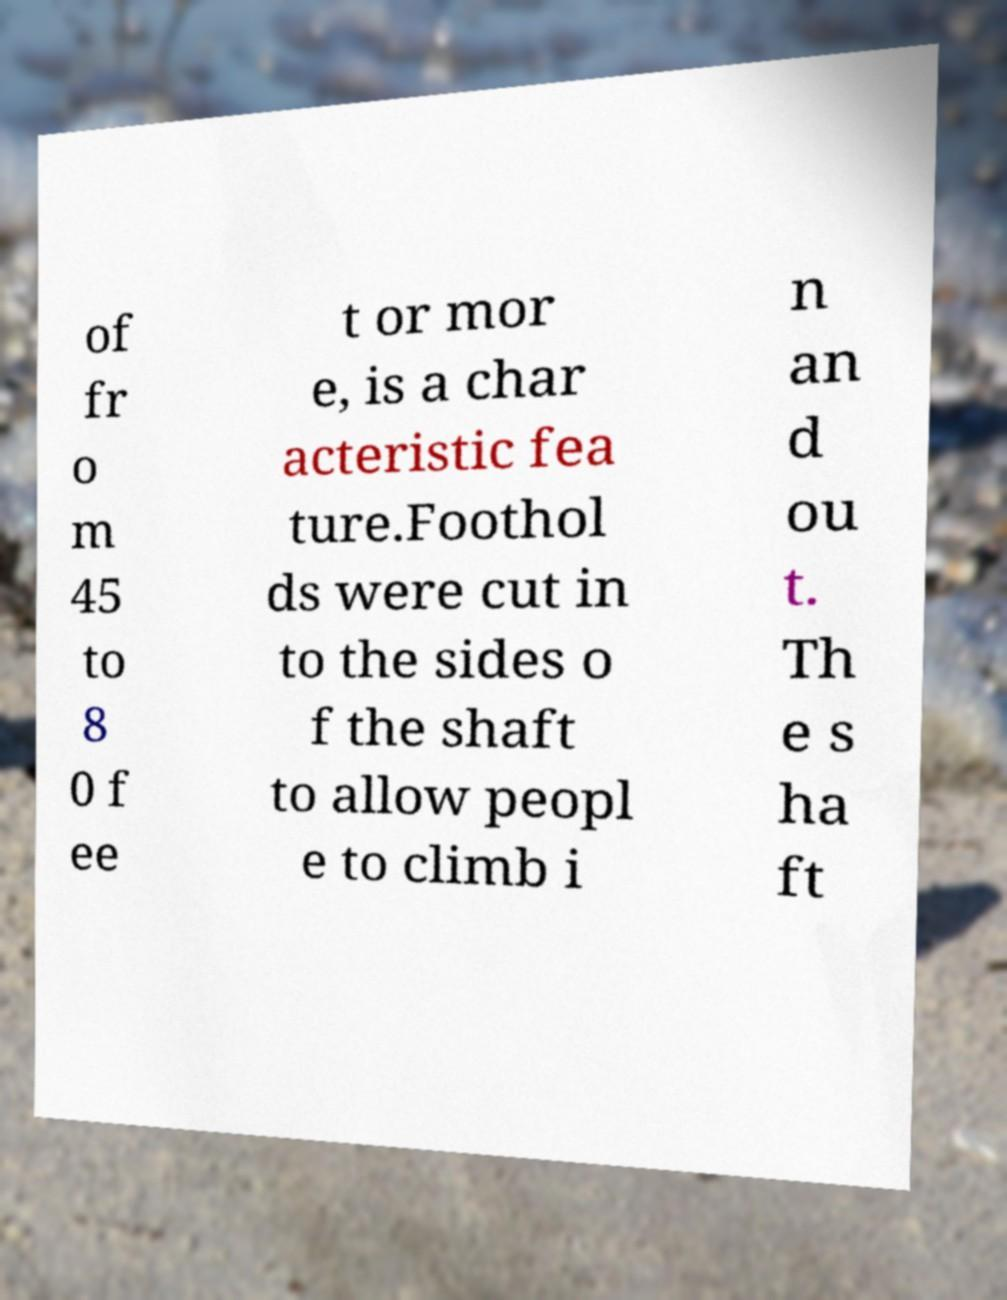I need the written content from this picture converted into text. Can you do that? of fr o m 45 to 8 0 f ee t or mor e, is a char acteristic fea ture.Foothol ds were cut in to the sides o f the shaft to allow peopl e to climb i n an d ou t. Th e s ha ft 